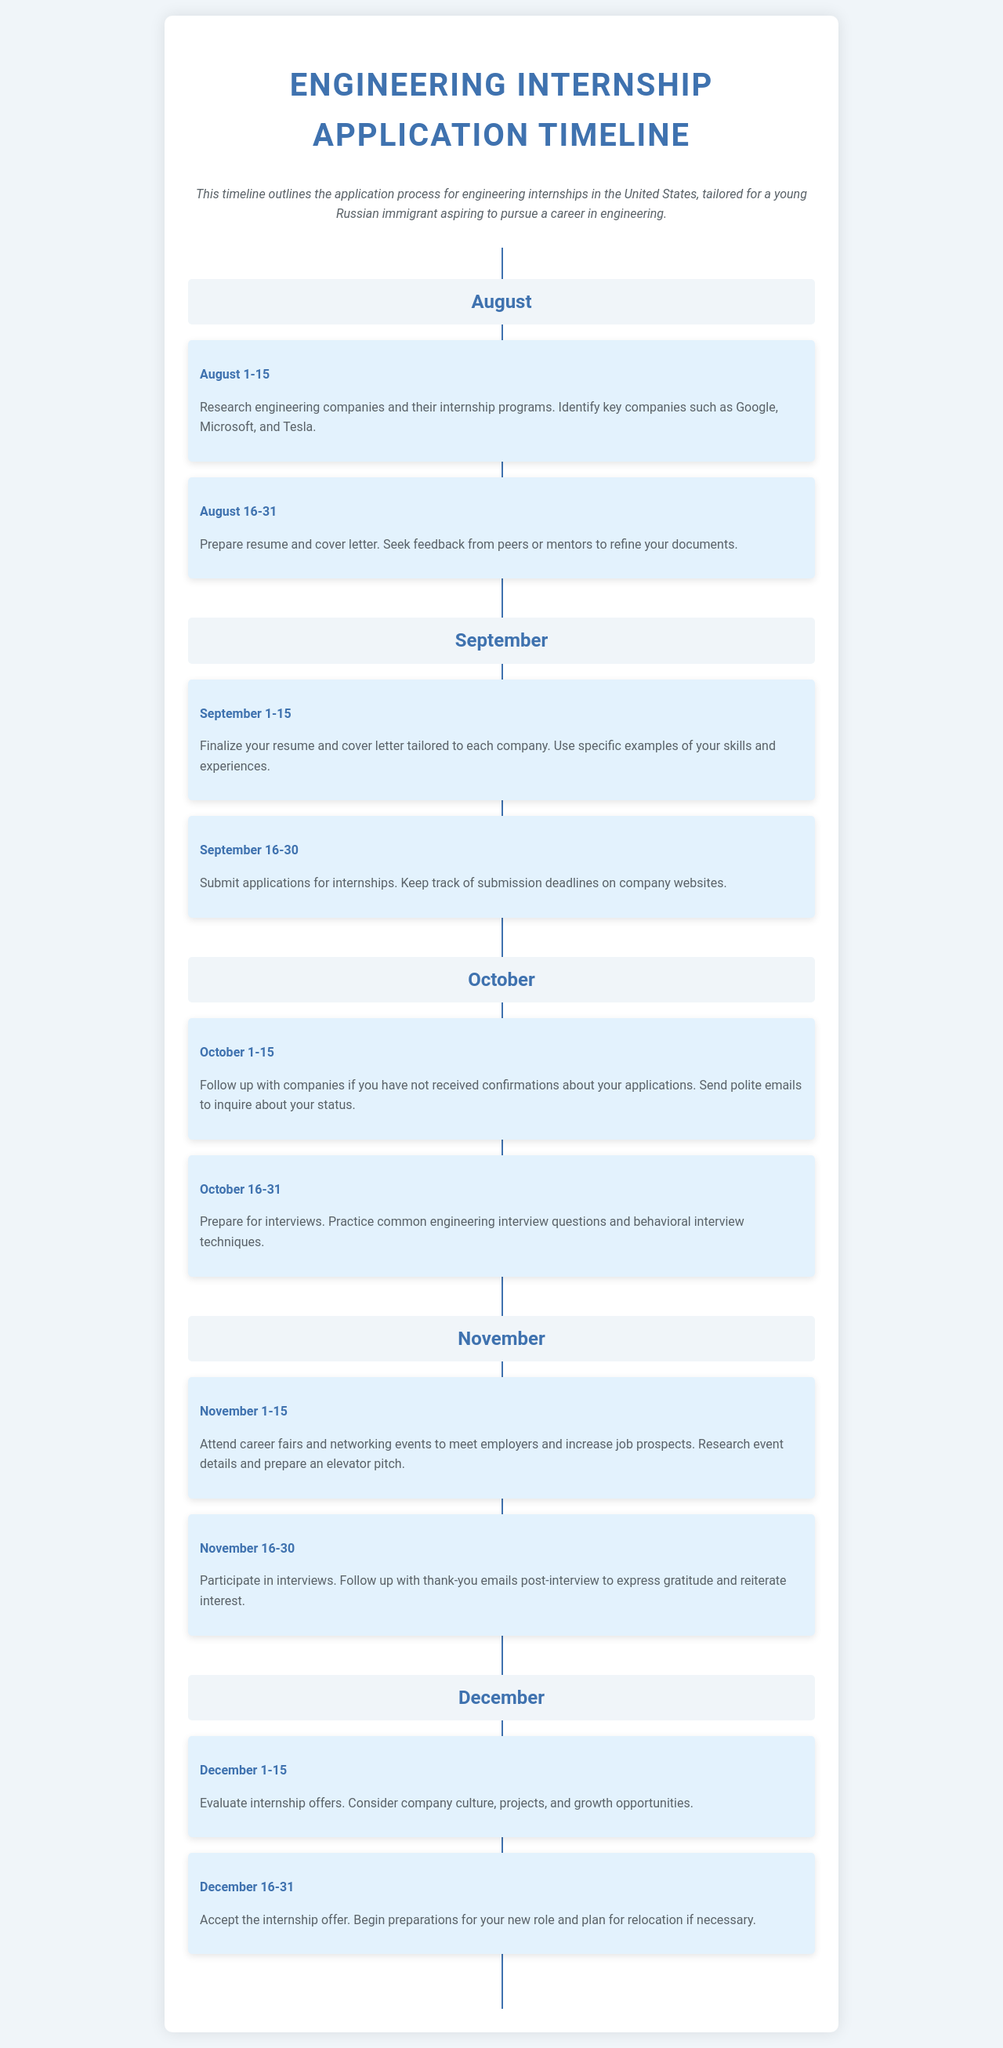what is the first activity in August? The first activity outlined in August is about researching engineering companies and their internship programs.
Answer: Research engineering companies and their internship programs what is the deadline for finalizing resume and cover letter? The deadline for finalizing your resume and cover letter is from September 1 to September 15.
Answer: September 1-15 how many engineering companies are mentioned for research? The document specifically mentions three key companies: Google, Microsoft, and Tesla.
Answer: Three what should you do between October 1-15? The task between October 1-15 involves following up with companies regarding application status.
Answer: Follow up with companies what is the main focus of the month of November? November focuses on attending career fairs and participating in interviews.
Answer: Attend career fairs and participate in interviews when should internship offers be evaluated? Internship offers should be evaluated from December 1 to December 15.
Answer: December 1-15 what is the final step in the application process? The final step in the application process is to accept the internship offer.
Answer: Accept the internship offer how should you follow up after interviews? You should follow up with thank-you emails after interviews.
Answer: Thank-you emails 